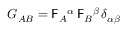<formula> <loc_0><loc_0><loc_500><loc_500>G _ { A B } = F _ { A ^ { \alpha } \, F _ { B ^ { \beta } \, \delta _ { \alpha \beta }</formula> 